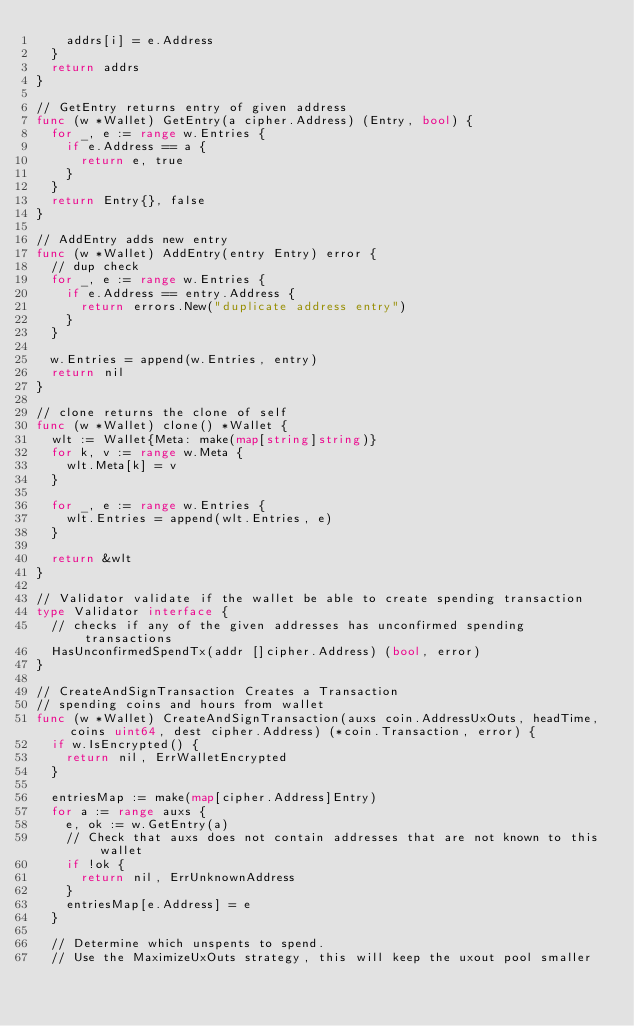Convert code to text. <code><loc_0><loc_0><loc_500><loc_500><_Go_>		addrs[i] = e.Address
	}
	return addrs
}

// GetEntry returns entry of given address
func (w *Wallet) GetEntry(a cipher.Address) (Entry, bool) {
	for _, e := range w.Entries {
		if e.Address == a {
			return e, true
		}
	}
	return Entry{}, false
}

// AddEntry adds new entry
func (w *Wallet) AddEntry(entry Entry) error {
	// dup check
	for _, e := range w.Entries {
		if e.Address == entry.Address {
			return errors.New("duplicate address entry")
		}
	}

	w.Entries = append(w.Entries, entry)
	return nil
}

// clone returns the clone of self
func (w *Wallet) clone() *Wallet {
	wlt := Wallet{Meta: make(map[string]string)}
	for k, v := range w.Meta {
		wlt.Meta[k] = v
	}

	for _, e := range w.Entries {
		wlt.Entries = append(wlt.Entries, e)
	}

	return &wlt
}

// Validator validate if the wallet be able to create spending transaction
type Validator interface {
	// checks if any of the given addresses has unconfirmed spending transactions
	HasUnconfirmedSpendTx(addr []cipher.Address) (bool, error)
}

// CreateAndSignTransaction Creates a Transaction
// spending coins and hours from wallet
func (w *Wallet) CreateAndSignTransaction(auxs coin.AddressUxOuts, headTime, coins uint64, dest cipher.Address) (*coin.Transaction, error) {
	if w.IsEncrypted() {
		return nil, ErrWalletEncrypted
	}

	entriesMap := make(map[cipher.Address]Entry)
	for a := range auxs {
		e, ok := w.GetEntry(a)
		// Check that auxs does not contain addresses that are not known to this wallet
		if !ok {
			return nil, ErrUnknownAddress
		}
		entriesMap[e.Address] = e
	}

	// Determine which unspents to spend.
	// Use the MaximizeUxOuts strategy, this will keep the uxout pool smaller</code> 